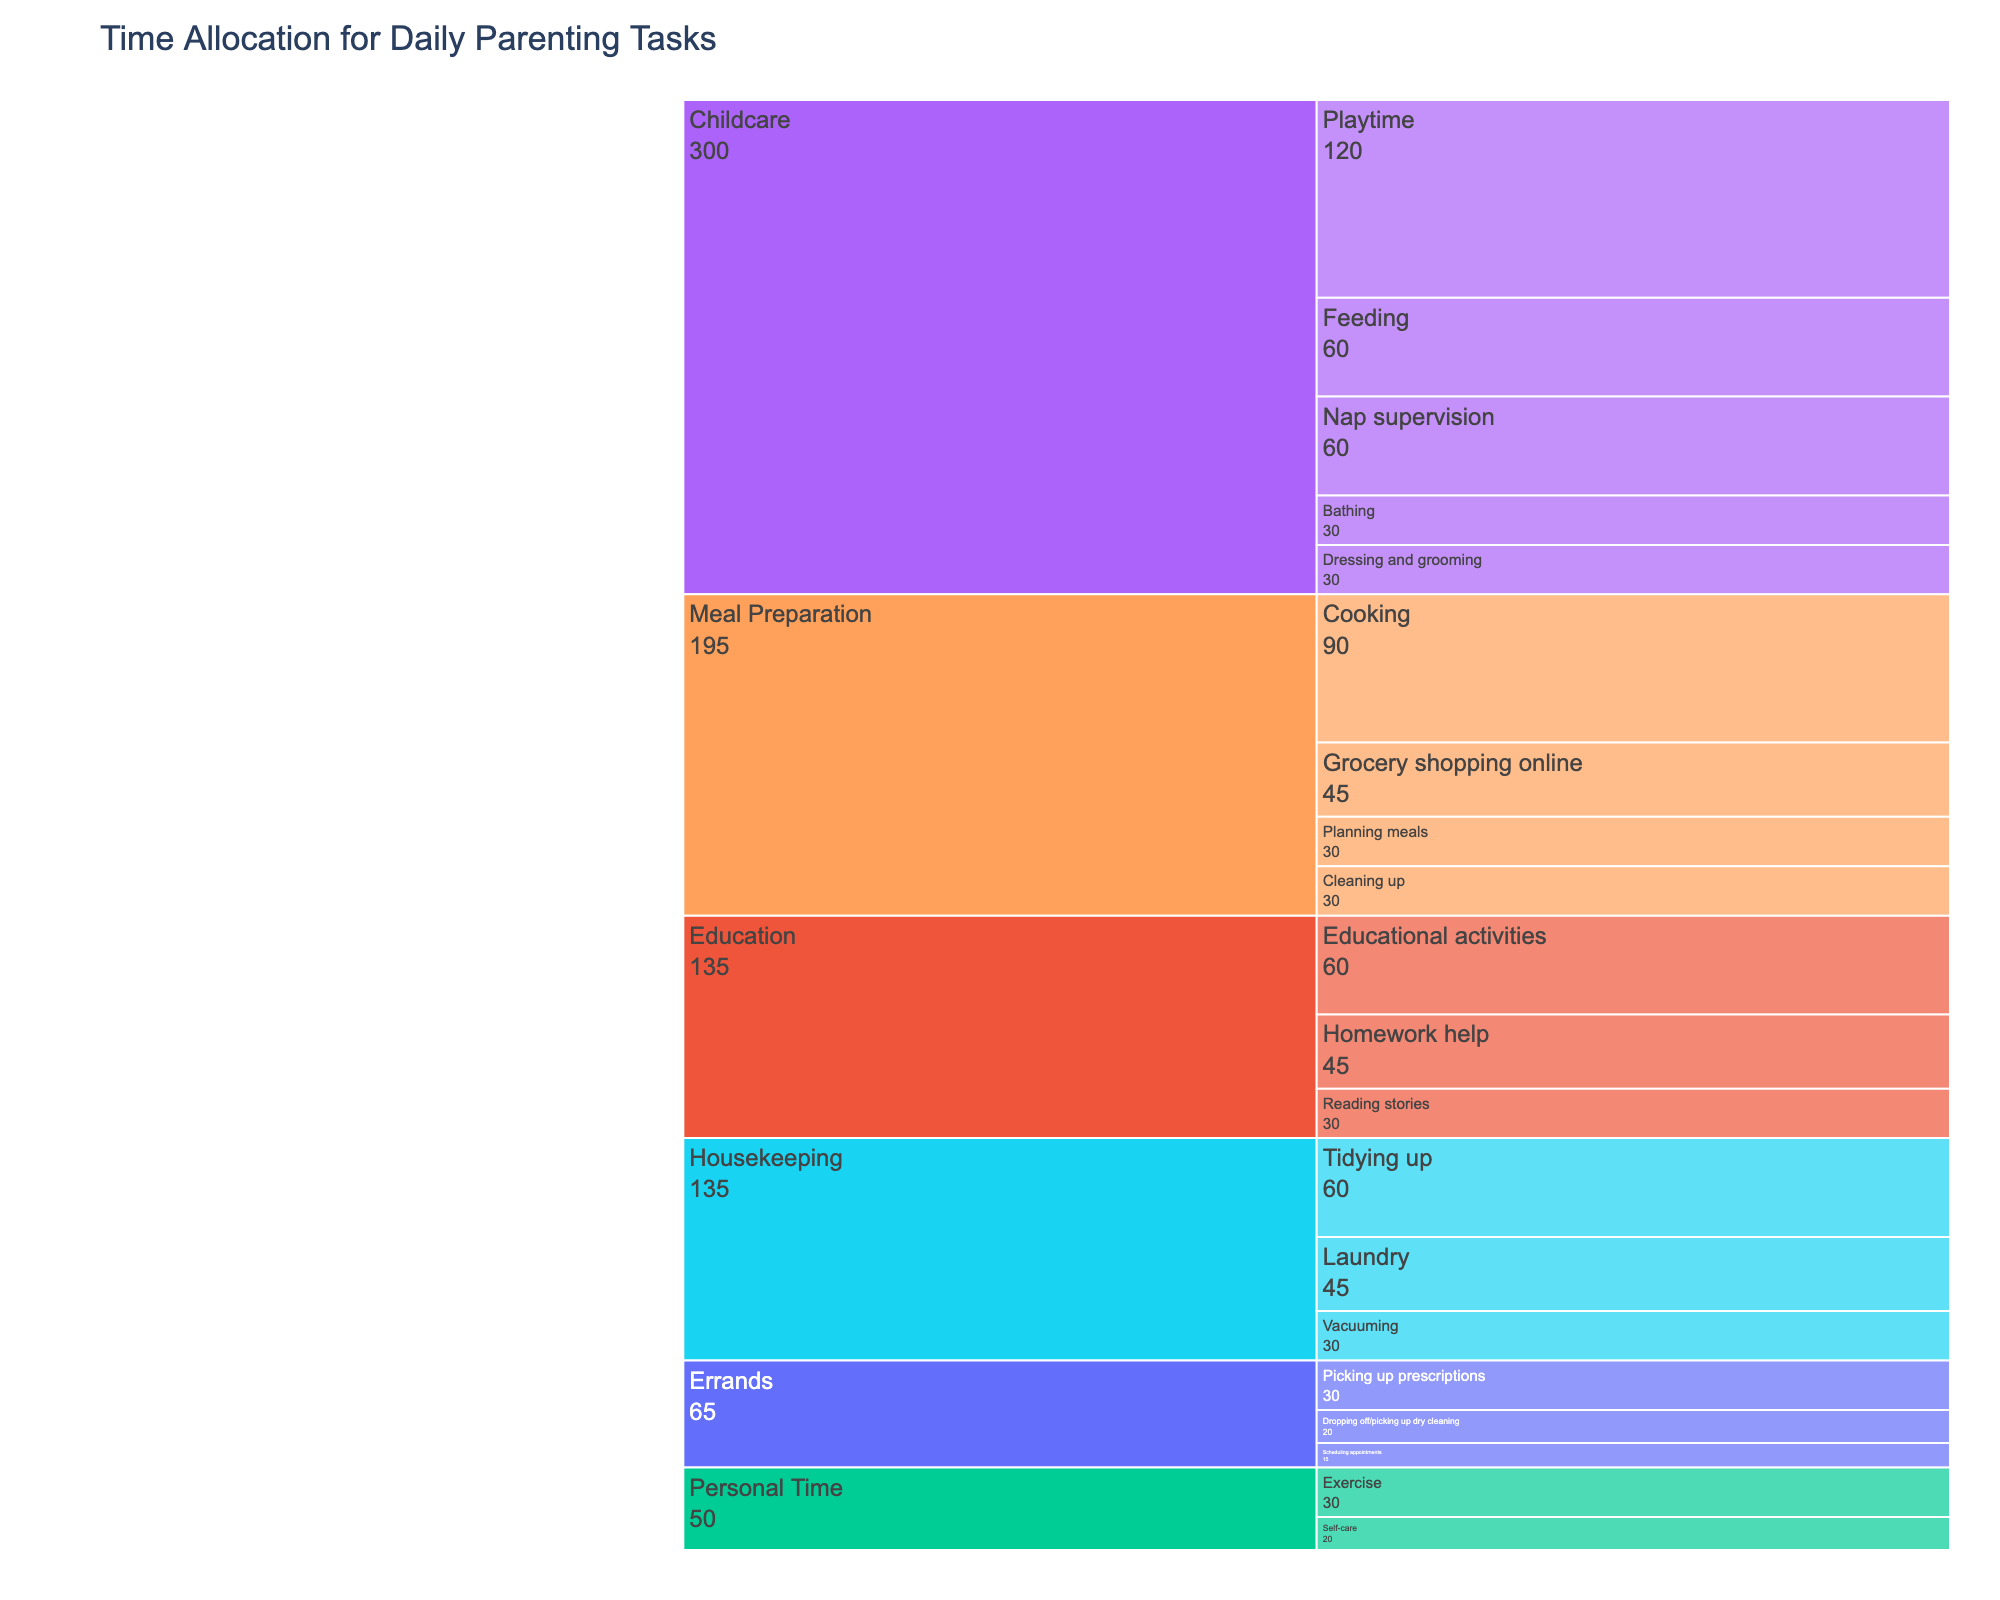What is the title of the chart? The title of the chart is located at the top and it generally describes what the chart is about.
Answer: Time Allocation for Daily Parenting Tasks Which task takes the most total time according to the chart? By examining the largest section in the icicle chart, which visually represents the task with the most minutes allocated to it, you can identify the task with the largest time allocation.
Answer: Childcare How much time is spent on Meal Preparation tasks in total? Add up the minutes allocated to each subtask under Meal Preparation: Planning meals (30) + Grocery shopping online (45) + Cooking (90) + Cleaning up (30).
Answer: 195 What is the percentage of time spent on Exercise relative to total Personal Time? Total minutes for Personal Time is Exercise (30) + Self-care (20) = 50. Exercise is 30 out of 50, so (30/50) * 100%.
Answer: 60% Is more time spent on educational activities or errands? Compare total minutes for Education (Reading stories (30) + Homework help (45) + Educational activities (60)) and Errands (Scheduling appointments (15) + Picking up prescriptions (30) + Dropping off/picking up dry cleaning (20)). Education totals 135 minutes, while Errands total 65 minutes.
Answer: Education What's the time difference between Cooking and Bathing? Subtract the minutes spent on Bathing (30) from those spent on Cooking (90).
Answer: 60 minutes Arrange the Housekeeping subtasks in descending order of time spent. Evaluate the time spent on each subtask under Housekeeping: Tidying up (60), Laundry (45), Vacuuming (30), and arrange them from highest to lowest.
Answer: Tidying up, Laundry, Vacuuming Which task category has the least total time allocation? Identify the smallest segment in the icicle chart corresponding to the task category with the least minutes.
Answer: Errands What fraction of the total time is spent on Childcare? Sum all subtasks under Childcare (30 + 60 + 120 + 60 + 30 = 300) and calculate it as a fraction of the total time for all tasks. Total time for all tasks is 30+45+90+30+30+60+120+60+30+30+45+60+45+60+30+15+30+20+30+20=850. So, 300/850.
Answer: 6/17 or ~35.3% 